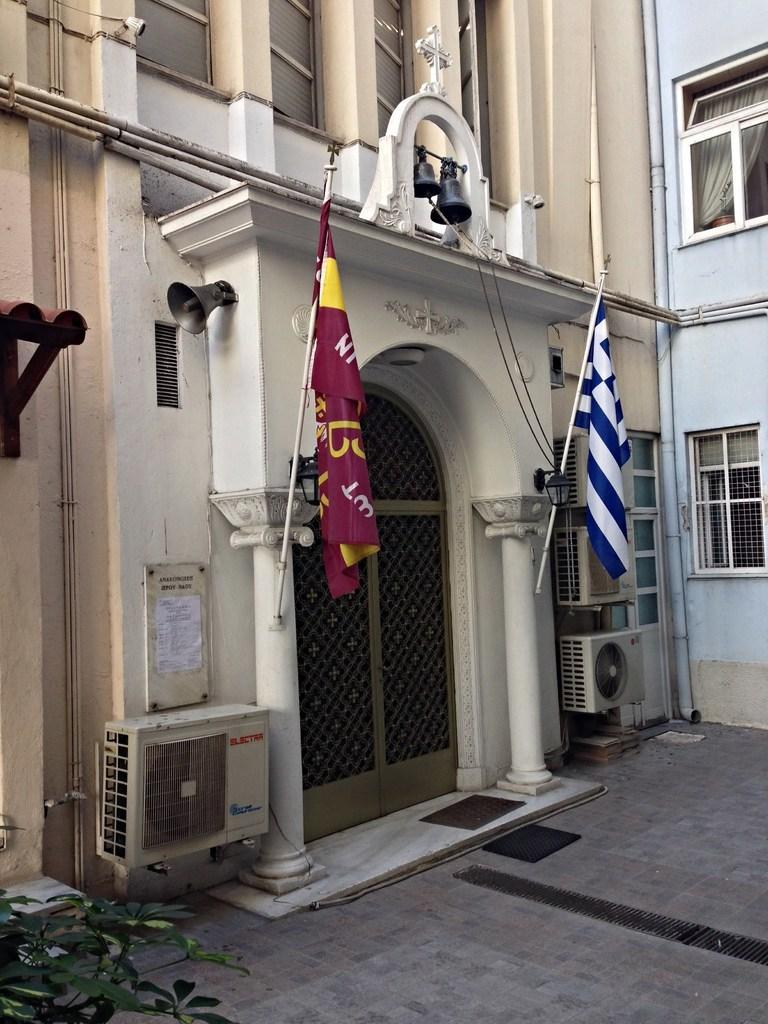In one or two sentences, can you explain what this image depicts? In this image I see buildings and I see 2 flags over here which are colorful and I see the bells over here and I see the path and I see green leaves on the stems and I see the pipes. 